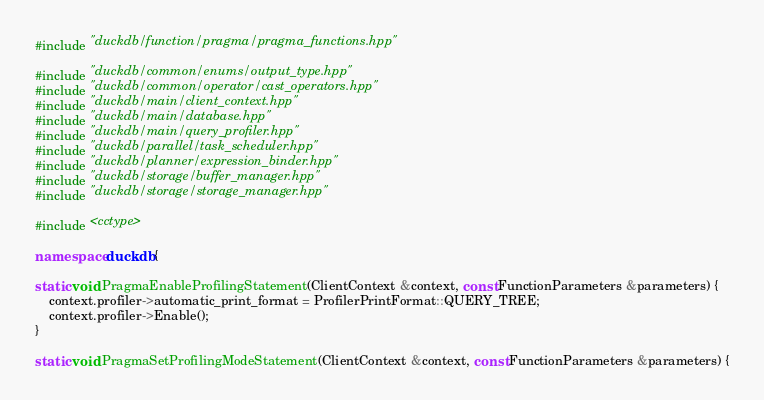<code> <loc_0><loc_0><loc_500><loc_500><_C++_>#include "duckdb/function/pragma/pragma_functions.hpp"

#include "duckdb/common/enums/output_type.hpp"
#include "duckdb/common/operator/cast_operators.hpp"
#include "duckdb/main/client_context.hpp"
#include "duckdb/main/database.hpp"
#include "duckdb/main/query_profiler.hpp"
#include "duckdb/parallel/task_scheduler.hpp"
#include "duckdb/planner/expression_binder.hpp"
#include "duckdb/storage/buffer_manager.hpp"
#include "duckdb/storage/storage_manager.hpp"

#include <cctype>

namespace duckdb {

static void PragmaEnableProfilingStatement(ClientContext &context, const FunctionParameters &parameters) {
	context.profiler->automatic_print_format = ProfilerPrintFormat::QUERY_TREE;
	context.profiler->Enable();
}

static void PragmaSetProfilingModeStatement(ClientContext &context, const FunctionParameters &parameters) {</code> 